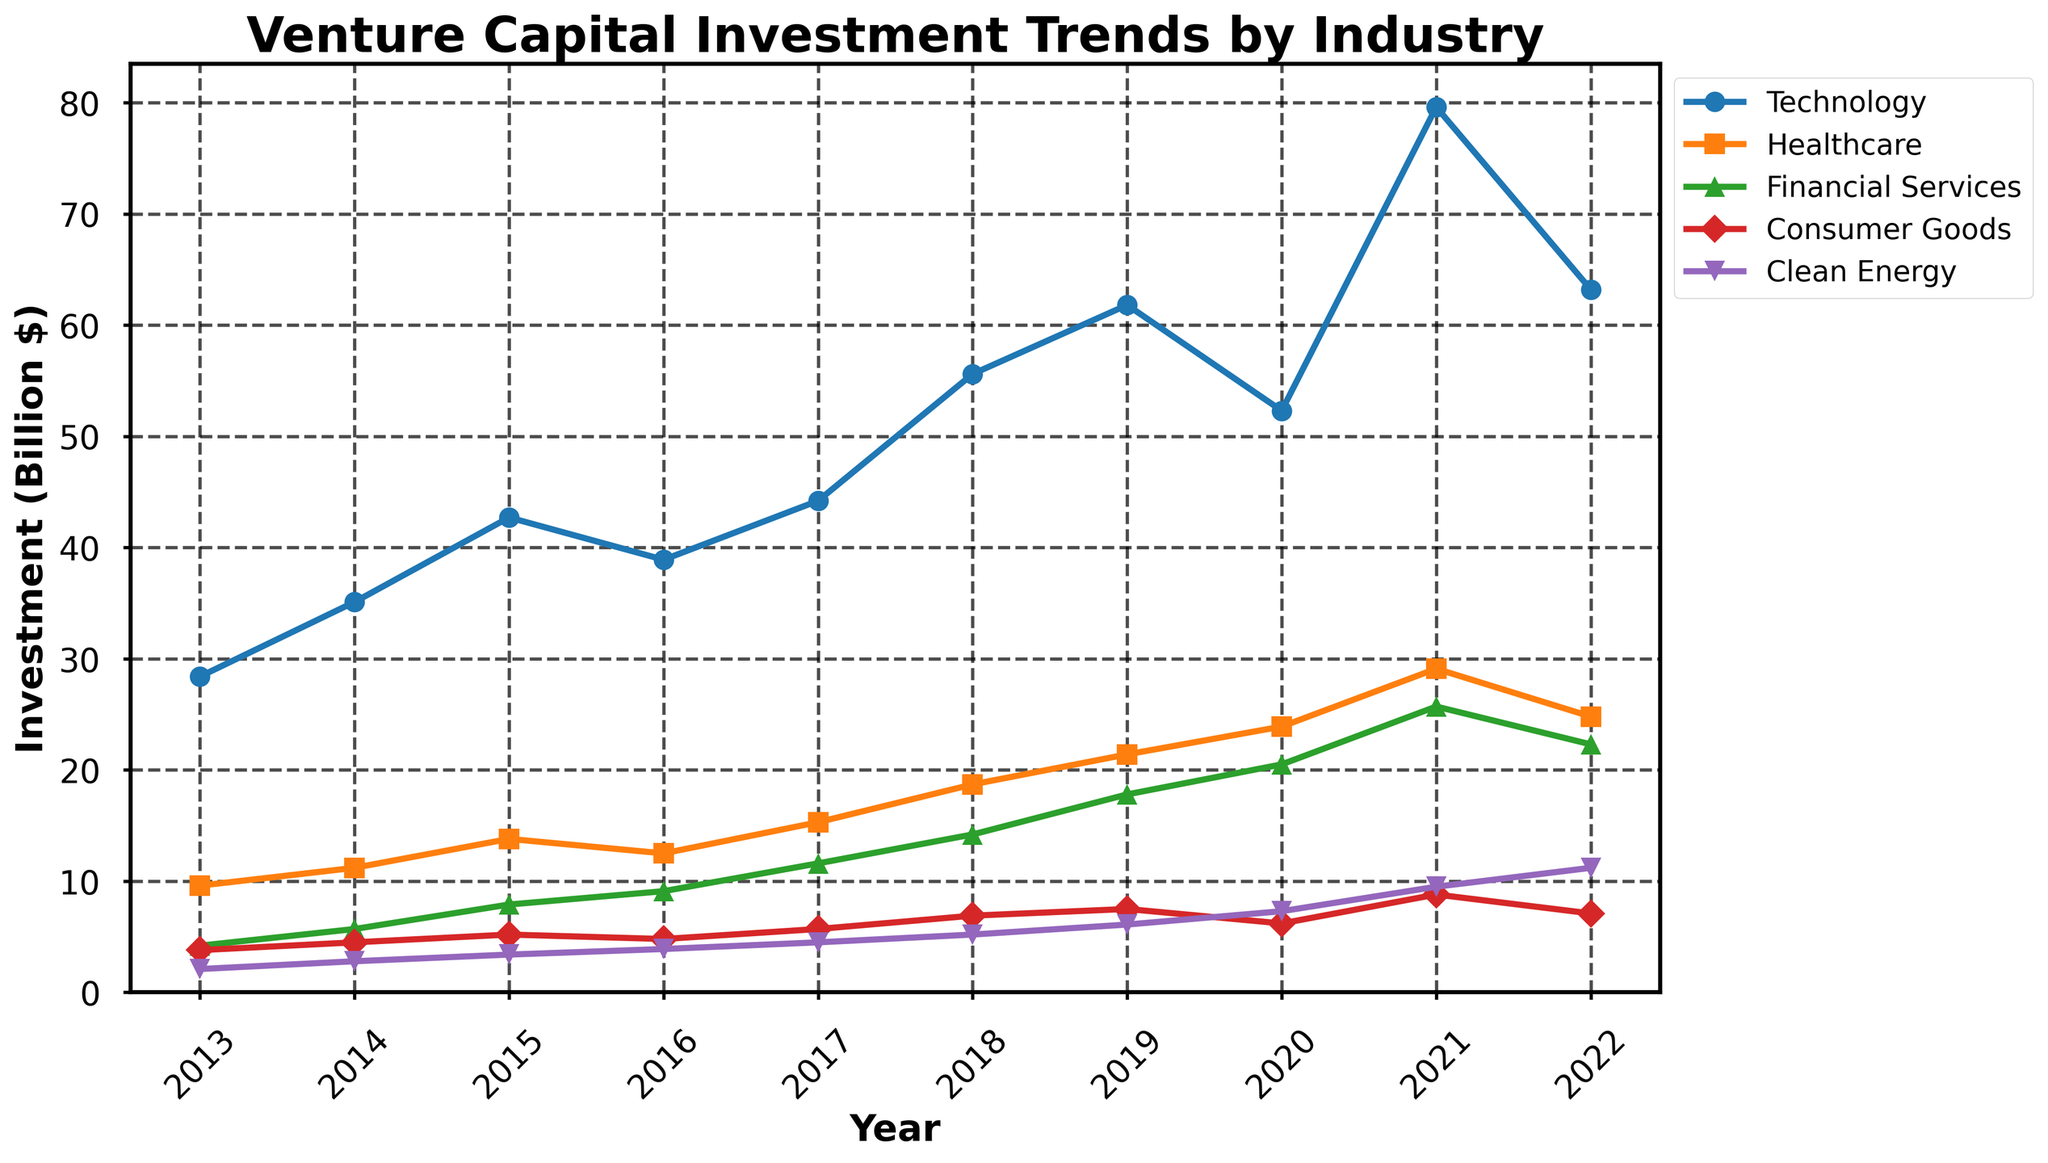What was the trend in venture capital investment in Technology from 2013 to 2022? The plot shows the investment in Technology increasing from 28.4 billion in 2013 to a peak of 79.6 billion in 2021, before decreasing to 63.2 billion in 2022. This indicates a general upward trend with a notable peak in 2021.
Answer: General upward trend with a peak in 2021 Which industry had the smallest amount of venture capital investment in 2013? By examining the y-axis values for each line in 2013, Clean Energy had the smallest investment, indicated by the lowest point on the graph at 2.1 billion dollars.
Answer: Clean Energy How did investments in Healthcare change from 2013 to 2022? The graph shows that investments in Healthcare increased steadily from 9.6 billion in 2013 to 29.1 billion in 2021 and then dipped to 24.8 billion in 2022.
Answer: Increased steadily and then dipped Between 2018 and 2020, which industry saw the highest relative increase in venture capital investments? By observing the slope of the lines between 2018 and 2020, Financial Services shows the highest relative increase, growing from 14.2 billion in 2018 to 20.5 billion in 2020.
Answer: Financial Services In 2021, what was the combined investment in Technology and Healthcare? The investment in Technology in 2021 was 79.6 billion, and in Healthcare, it was 29.1 billion. Summing these values gives 79.6 + 29.1 = 108.7 billion.
Answer: 108.7 billion Which two industries had the closest venture capital investments in 2019? By comparing the y-axis values for 2019, Consumer Goods and Clean Energy had investments of 7.5 billion and 6.1 billion respectively, which are closer compared to other pairs.
Answer: Consumer Goods and Clean Energy What was the average investment in Financial Services over the decade? The annual investments in Financial Services from 2013 to 2022 are: 4.2, 5.7, 7.9, 9.1, 11.6, 14.2, 17.8, 20.5, 25.7, 22.3. The sum is 139.0 and the average is 139.0 / 10 = 13.9 billion.
Answer: 13.9 billion Did any industry see a continuous investment increase from 2013 to 2021? By looking at the trend lines, Healthcare shows a continuous increase in investment each year from 2013 to 2021 without any dip.
Answer: Healthcare In 2022, which industry had the largest drop in investment compared to 2021? Comparing 2022 to 2021, Technology saw the largest drop from 79.6 billion in 2021 to 63.2 billion in 2022, a difference of 16.4 billion.
Answer: Technology Which industry's investment trend was the least volatile from 2013 to 2022? By comparing the smoothness and steepness of the lines, Consumer Goods shows the least volatile trend with the smallest fluctuations over the decade.
Answer: Consumer Goods 